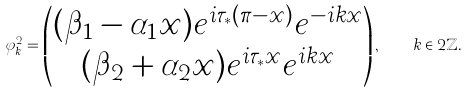<formula> <loc_0><loc_0><loc_500><loc_500>\varphi ^ { 2 } _ { k } = \begin{pmatrix} ( \beta _ { 1 } - \alpha _ { 1 } x ) e ^ { i \tau _ { * } ( \pi - x ) } e ^ { - i k x } \\ ( \beta _ { 2 } + \alpha _ { 2 } x ) e ^ { i \tau _ { * } x } e ^ { i k x } \end{pmatrix} , \quad k \in 2 \mathbb { Z } .</formula> 